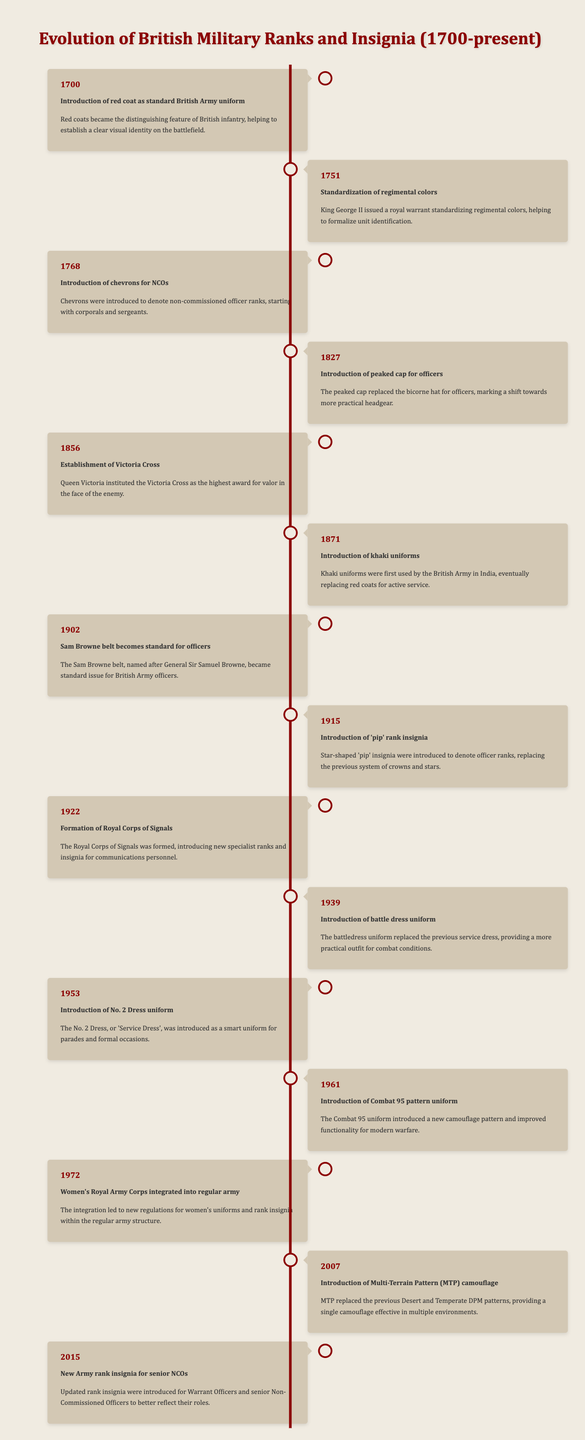What year was the Victoria Cross established? The table lists the establishment of the Victoria Cross in the year 1856.
Answer: 1856 What event occurred in 1902? According to the table, in 1902, the Sam Browne belt became standard for officers.
Answer: Sam Browne belt becomes standard for officers Was khaki introduced before or after the red coat? The introduction of the red coat was in 1700, while khaki uniforms were introduced in 1871, which is after red coats.
Answer: After How many years passed between the introduction of the peaked cap for officers and the establishment of the Victoria Cross? The peaked cap was introduced in 1827 and the Victoria Cross in 1856; thus, 1856 - 1827 equals 29 years.
Answer: 29 years Which event marked the integration of women into the regular army? The integration of the Women's Royal Army Corps into the regular army occurred in 1972.
Answer: Women's Royal Army Corps integrated into regular army Which uniform replaced the previous service dress in 1939? The table indicates that the battledress uniform replaced the previous service dress in 1939.
Answer: Battle dress uniform Between which two years did the introduction of new camouflage patterns occur? The introduction of the Combat 95 pattern uniform was in 1961, and the Multi-Terrain Pattern (MTP) camouflage was introduced in 2007. Therefore, the gap is from 1961 to 2007.
Answer: 1961 and 2007 How many events were recorded in the 20th century (1900s)? By reviewing the table, the events occurring in the 20th century are in the years 1902, 1915, 1922, 1939, 1953, 1961, 1972, and 2007. This accounts for 8 events in total.
Answer: 8 events Was the introduction of chevrons for NCOs before or after the formation of the Royal Corps of Signals? Chevrons were introduced in 1768 and the Royal Corps of Signals was formed in 1922, indicating that the introduction of chevrons occurred before.
Answer: Before 